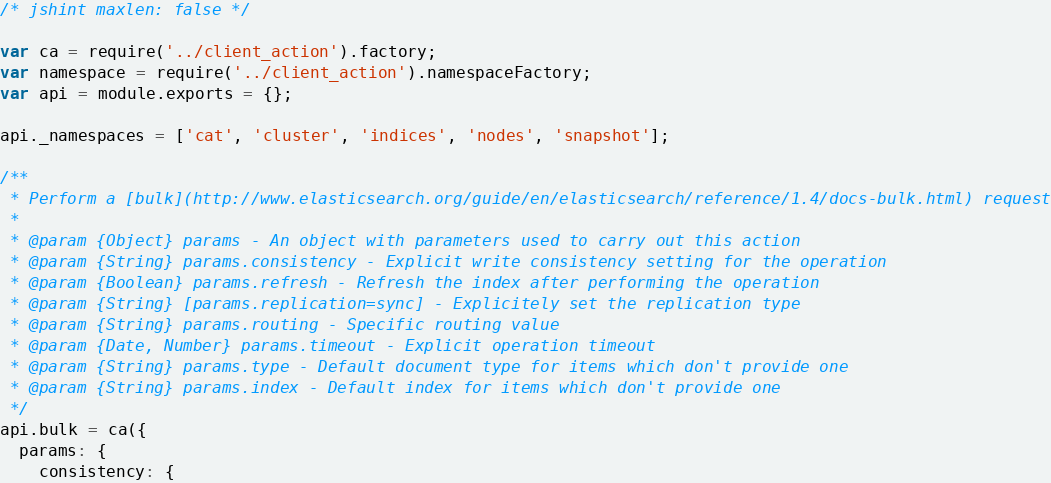Convert code to text. <code><loc_0><loc_0><loc_500><loc_500><_JavaScript_>/* jshint maxlen: false */

var ca = require('../client_action').factory;
var namespace = require('../client_action').namespaceFactory;
var api = module.exports = {};

api._namespaces = ['cat', 'cluster', 'indices', 'nodes', 'snapshot'];

/**
 * Perform a [bulk](http://www.elasticsearch.org/guide/en/elasticsearch/reference/1.4/docs-bulk.html) request
 *
 * @param {Object} params - An object with parameters used to carry out this action
 * @param {String} params.consistency - Explicit write consistency setting for the operation
 * @param {Boolean} params.refresh - Refresh the index after performing the operation
 * @param {String} [params.replication=sync] - Explicitely set the replication type
 * @param {String} params.routing - Specific routing value
 * @param {Date, Number} params.timeout - Explicit operation timeout
 * @param {String} params.type - Default document type for items which don't provide one
 * @param {String} params.index - Default index for items which don't provide one
 */
api.bulk = ca({
  params: {
    consistency: {</code> 